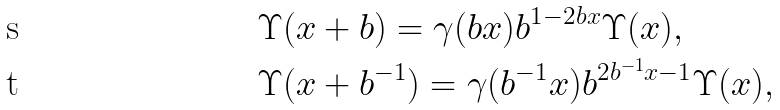<formula> <loc_0><loc_0><loc_500><loc_500>& \Upsilon ( x + b ) = \gamma ( b x ) b ^ { 1 - 2 b x } \Upsilon ( x ) , \\ & \Upsilon ( x + b ^ { - 1 } ) = \gamma ( b ^ { - 1 } x ) b ^ { 2 b ^ { - 1 } x - 1 } \Upsilon ( x ) ,</formula> 